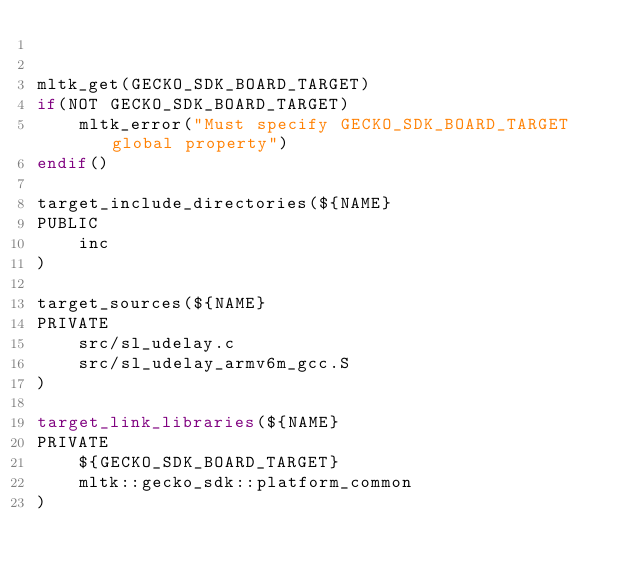<code> <loc_0><loc_0><loc_500><loc_500><_CMake_>

mltk_get(GECKO_SDK_BOARD_TARGET)
if(NOT GECKO_SDK_BOARD_TARGET)
    mltk_error("Must specify GECKO_SDK_BOARD_TARGET global property")
endif()

target_include_directories(${NAME} 
PUBLIC
    inc
)

target_sources(${NAME} 
PRIVATE 
    src/sl_udelay.c
    src/sl_udelay_armv6m_gcc.S
)

target_link_libraries(${NAME}
PRIVATE 
    ${GECKO_SDK_BOARD_TARGET}
    mltk::gecko_sdk::platform_common
)</code> 